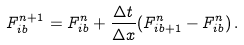Convert formula to latex. <formula><loc_0><loc_0><loc_500><loc_500>F ^ { n + 1 } _ { i b } = F ^ { n } _ { i b } + \frac { \Delta t } { \Delta x } ( F ^ { n } _ { i b + 1 } - F ^ { n } _ { i b } ) \, .</formula> 